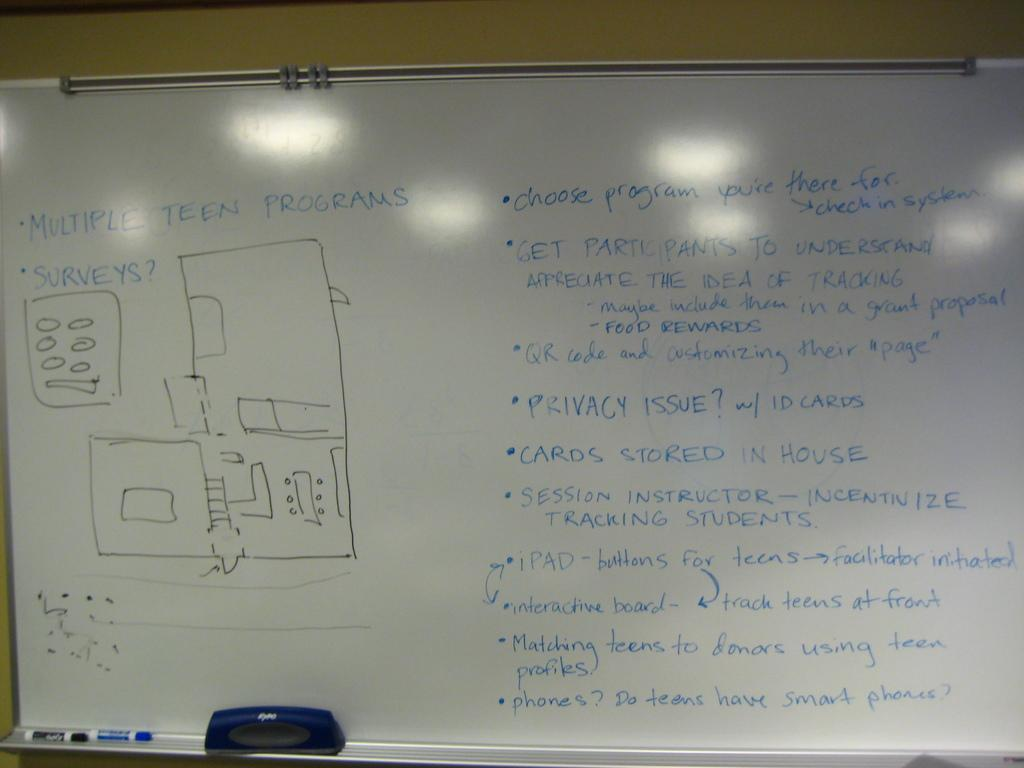<image>
Present a compact description of the photo's key features. A bullet point list starts with "multiple teen programs." 